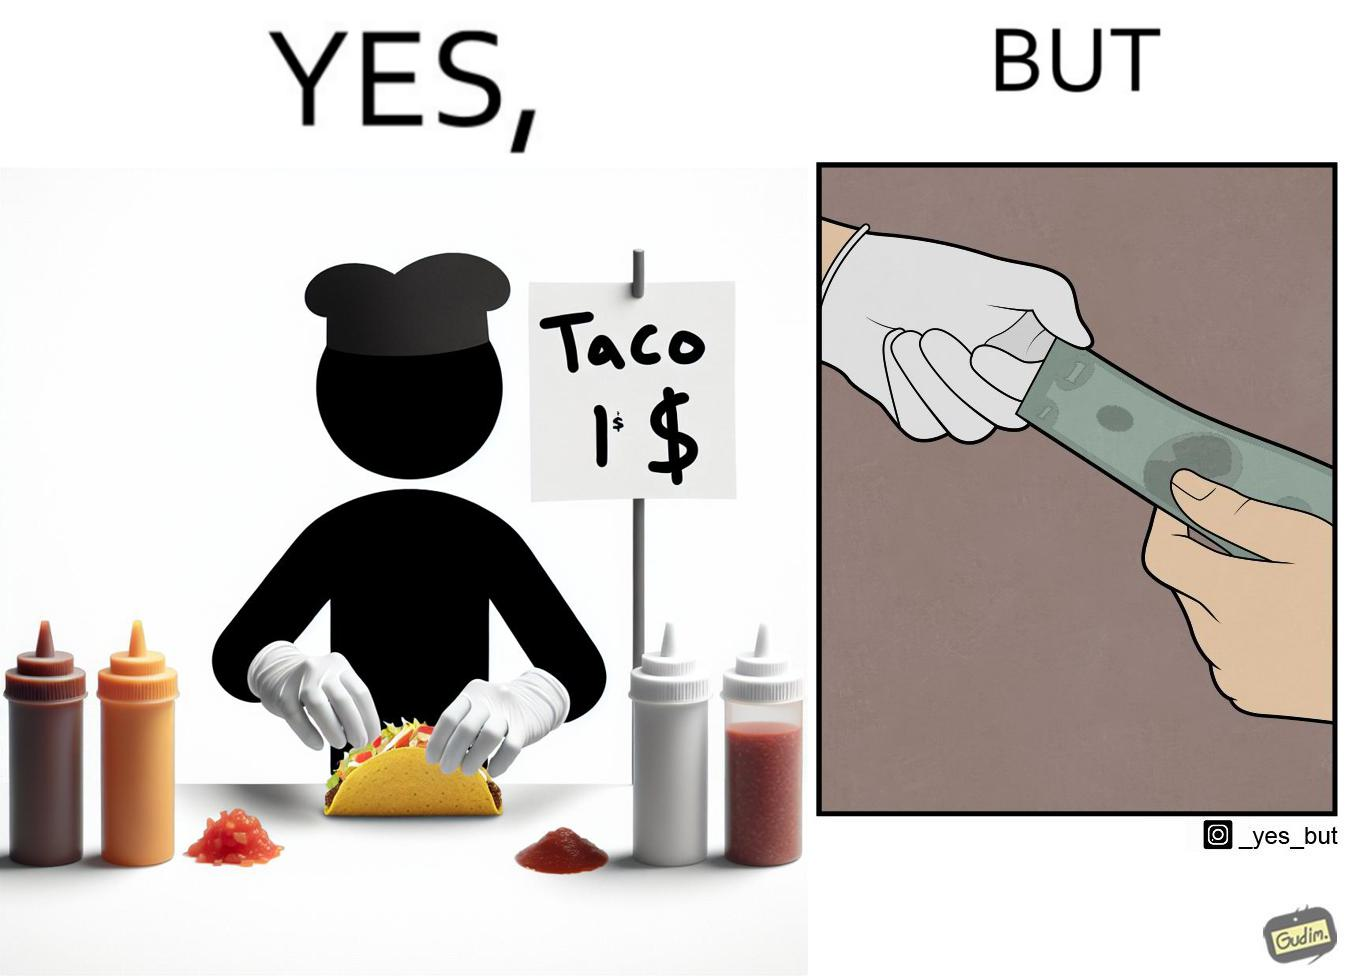Describe the contrast between the left and right parts of this image. In the left part of the image: The image shows a person wearing white gloves preparing a taco in their hand. There are several condiments on the table. There is also a note that says "TACO 1$" indicating that each taco is sold for only $1. In the right part of the image: The image shows two people transacting $1 among them. One of them is wearing white gloves and one of them is not wearing any gloves. 